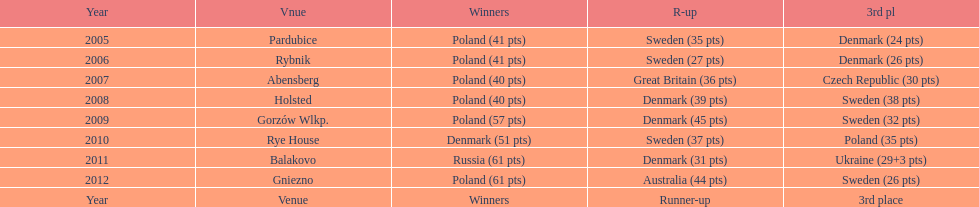After 2008 how many points total were scored by winners? 230. 